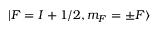Convert formula to latex. <formula><loc_0><loc_0><loc_500><loc_500>| F = I + 1 / 2 , m _ { F } = \pm F \rangle</formula> 